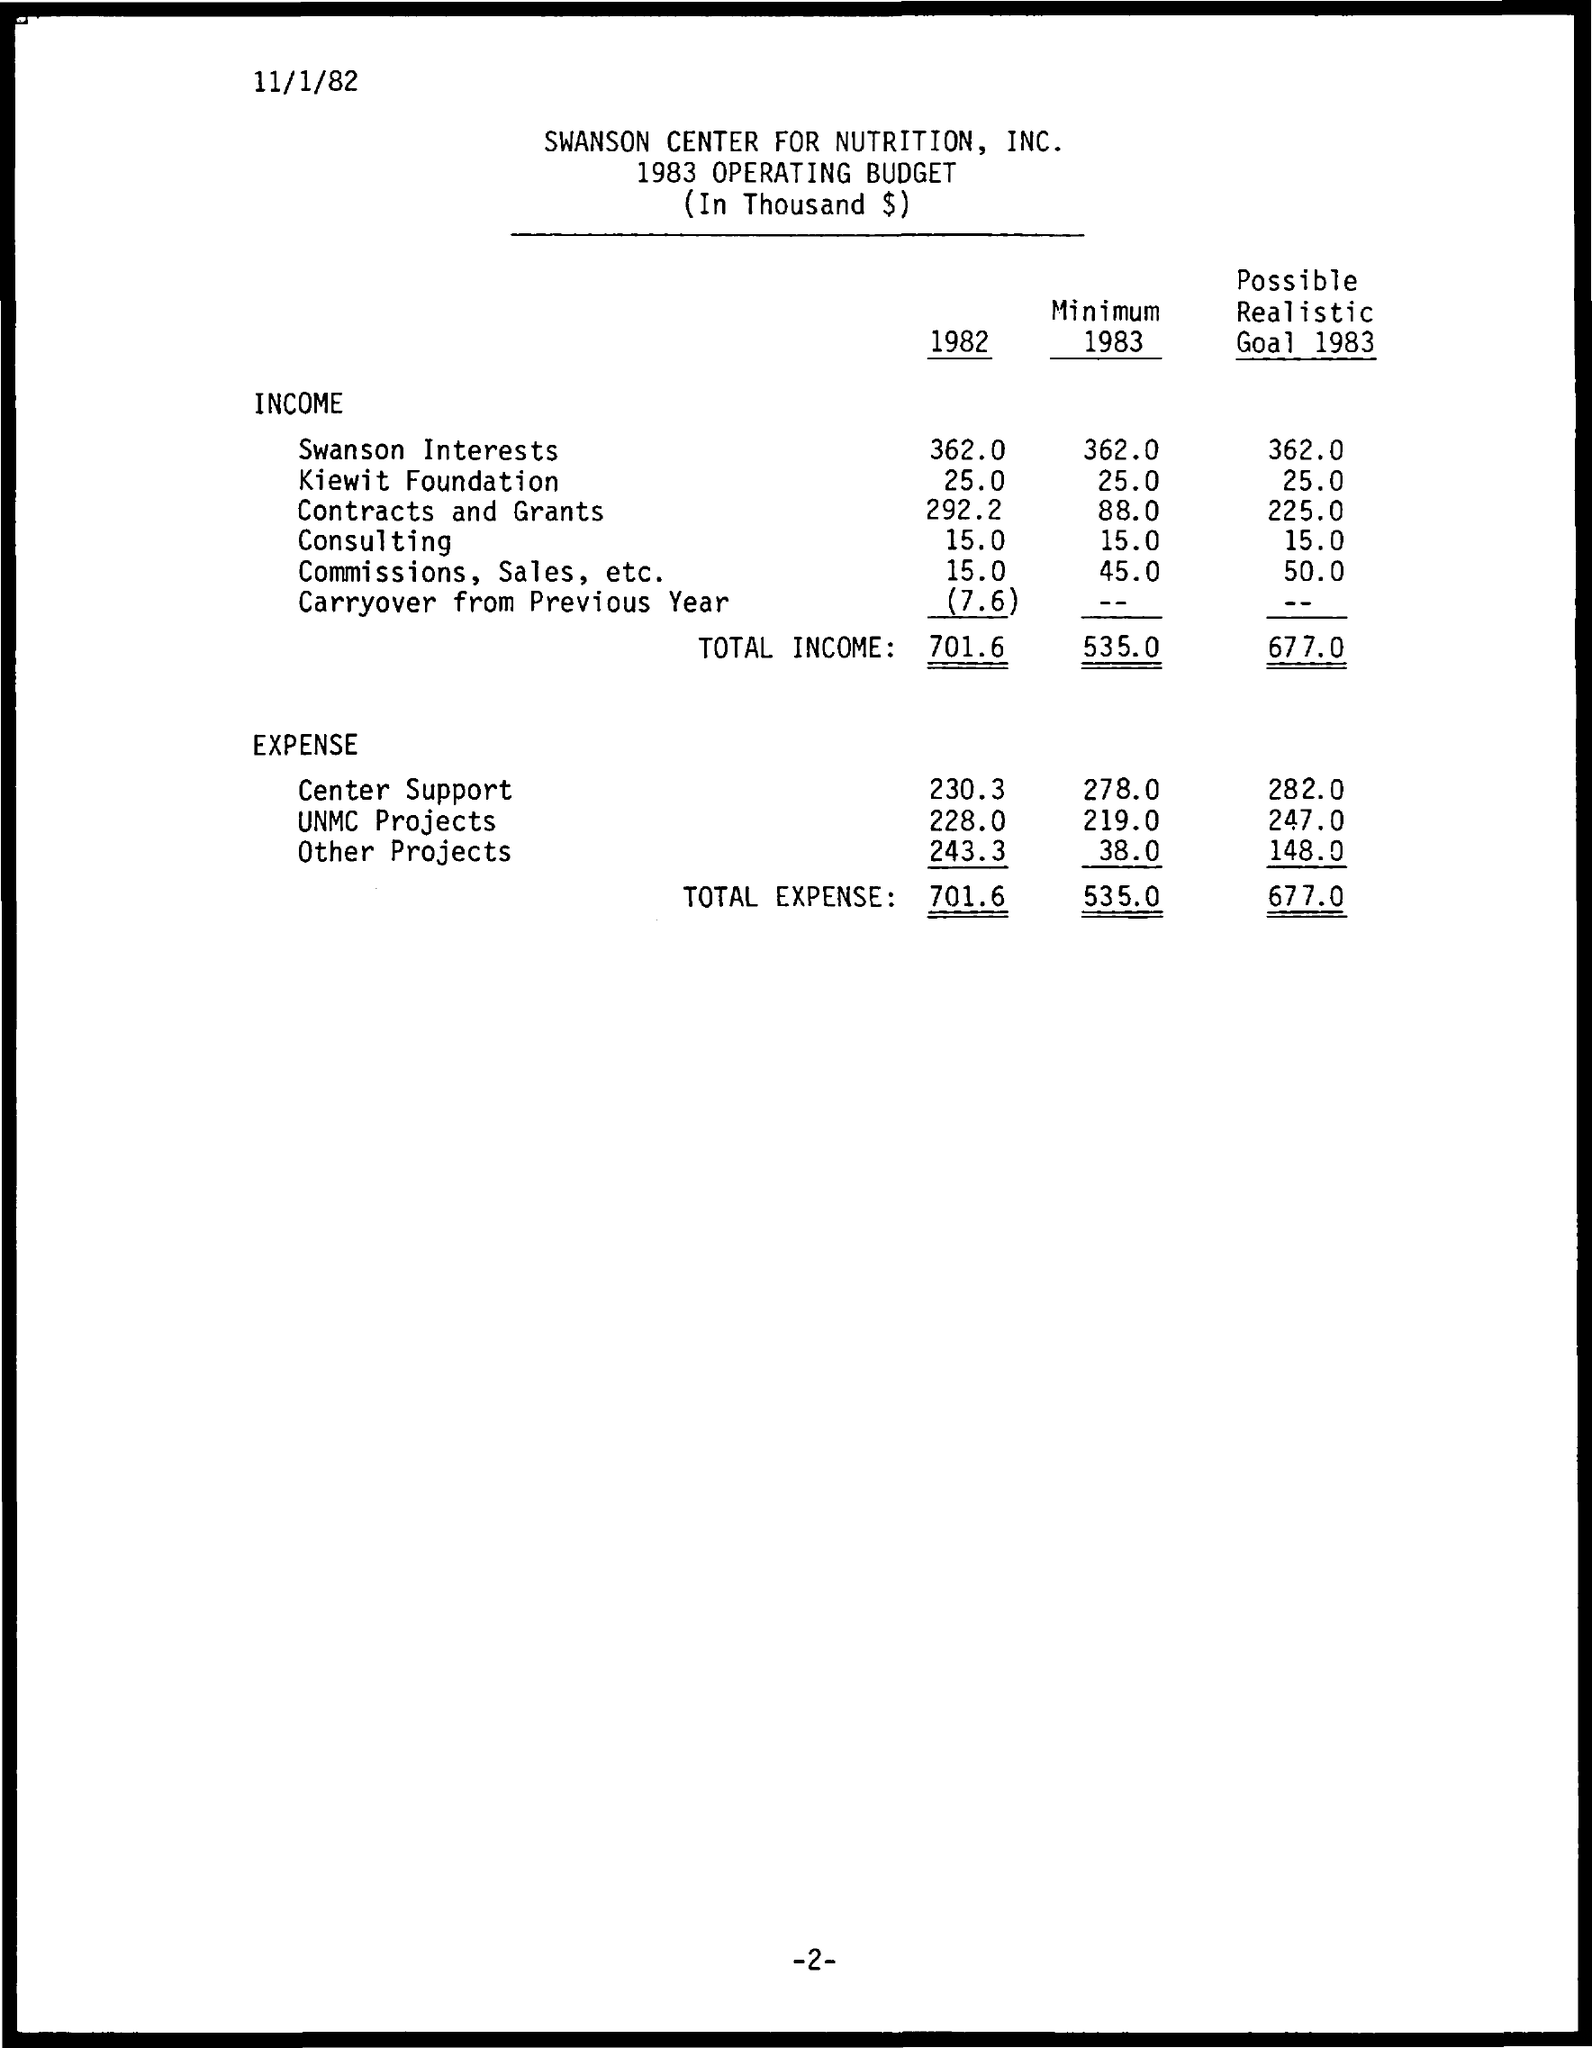When is the document dated?
Offer a very short reply. 11/1/82. In the year 1982, which expense was the highest?
Provide a succinct answer. Other Projects. What is the document about?
Give a very brief answer. 1983 OPERATING BUDGET. 